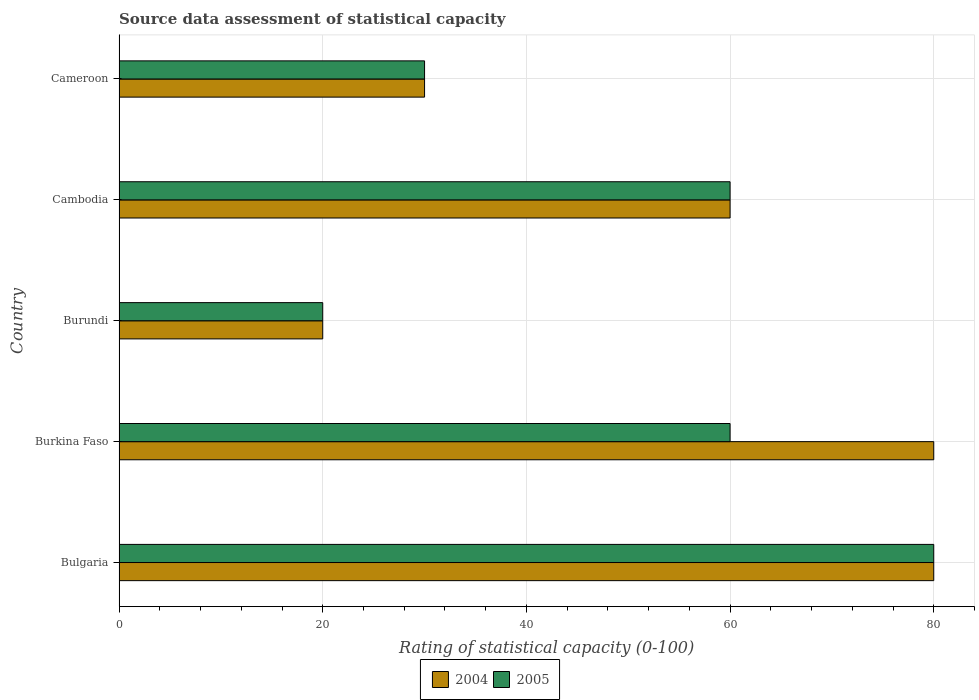Are the number of bars per tick equal to the number of legend labels?
Keep it short and to the point. Yes. Are the number of bars on each tick of the Y-axis equal?
Your response must be concise. Yes. What is the label of the 3rd group of bars from the top?
Ensure brevity in your answer.  Burundi. In which country was the rating of statistical capacity in 2005 maximum?
Make the answer very short. Bulgaria. In which country was the rating of statistical capacity in 2005 minimum?
Your answer should be compact. Burundi. What is the total rating of statistical capacity in 2005 in the graph?
Your answer should be very brief. 250. What is the difference between the rating of statistical capacity in 2004 in Bulgaria and that in Cameroon?
Your response must be concise. 50. What is the average rating of statistical capacity in 2005 per country?
Offer a terse response. 50. In how many countries, is the rating of statistical capacity in 2004 greater than 48 ?
Your response must be concise. 3. What is the ratio of the rating of statistical capacity in 2004 in Burkina Faso to that in Burundi?
Provide a short and direct response. 4. What is the difference between the highest and the second highest rating of statistical capacity in 2005?
Your answer should be very brief. 20. What does the 1st bar from the top in Cambodia represents?
Make the answer very short. 2005. Are all the bars in the graph horizontal?
Ensure brevity in your answer.  Yes. Are the values on the major ticks of X-axis written in scientific E-notation?
Ensure brevity in your answer.  No. Does the graph contain any zero values?
Ensure brevity in your answer.  No. Does the graph contain grids?
Your answer should be very brief. Yes. How are the legend labels stacked?
Provide a succinct answer. Horizontal. What is the title of the graph?
Provide a short and direct response. Source data assessment of statistical capacity. What is the label or title of the X-axis?
Your response must be concise. Rating of statistical capacity (0-100). What is the Rating of statistical capacity (0-100) in 2005 in Bulgaria?
Offer a very short reply. 80. What is the Rating of statistical capacity (0-100) in 2004 in Burundi?
Keep it short and to the point. 20. What is the Rating of statistical capacity (0-100) in 2004 in Cambodia?
Make the answer very short. 60. What is the Rating of statistical capacity (0-100) in 2005 in Cameroon?
Ensure brevity in your answer.  30. Across all countries, what is the maximum Rating of statistical capacity (0-100) in 2005?
Your response must be concise. 80. Across all countries, what is the minimum Rating of statistical capacity (0-100) of 2005?
Ensure brevity in your answer.  20. What is the total Rating of statistical capacity (0-100) of 2004 in the graph?
Your answer should be very brief. 270. What is the total Rating of statistical capacity (0-100) in 2005 in the graph?
Ensure brevity in your answer.  250. What is the difference between the Rating of statistical capacity (0-100) of 2004 in Bulgaria and that in Burkina Faso?
Offer a very short reply. 0. What is the difference between the Rating of statistical capacity (0-100) of 2005 in Bulgaria and that in Burkina Faso?
Provide a short and direct response. 20. What is the difference between the Rating of statistical capacity (0-100) of 2004 in Bulgaria and that in Burundi?
Ensure brevity in your answer.  60. What is the difference between the Rating of statistical capacity (0-100) of 2005 in Bulgaria and that in Burundi?
Your answer should be compact. 60. What is the difference between the Rating of statistical capacity (0-100) in 2004 in Burkina Faso and that in Burundi?
Your response must be concise. 60. What is the difference between the Rating of statistical capacity (0-100) of 2005 in Burkina Faso and that in Burundi?
Your answer should be very brief. 40. What is the difference between the Rating of statistical capacity (0-100) in 2004 in Burkina Faso and that in Cameroon?
Offer a terse response. 50. What is the difference between the Rating of statistical capacity (0-100) in 2005 in Burkina Faso and that in Cameroon?
Your answer should be very brief. 30. What is the difference between the Rating of statistical capacity (0-100) of 2004 in Burundi and that in Cambodia?
Ensure brevity in your answer.  -40. What is the difference between the Rating of statistical capacity (0-100) in 2005 in Burundi and that in Cambodia?
Your answer should be very brief. -40. What is the difference between the Rating of statistical capacity (0-100) of 2005 in Burundi and that in Cameroon?
Your answer should be very brief. -10. What is the difference between the Rating of statistical capacity (0-100) in 2004 in Bulgaria and the Rating of statistical capacity (0-100) in 2005 in Cambodia?
Your response must be concise. 20. What is the difference between the Rating of statistical capacity (0-100) of 2004 in Burkina Faso and the Rating of statistical capacity (0-100) of 2005 in Burundi?
Provide a succinct answer. 60. What is the difference between the Rating of statistical capacity (0-100) in 2004 in Burkina Faso and the Rating of statistical capacity (0-100) in 2005 in Cambodia?
Provide a short and direct response. 20. What is the difference between the Rating of statistical capacity (0-100) in 2004 in Burkina Faso and the Rating of statistical capacity (0-100) in 2005 in Cameroon?
Provide a succinct answer. 50. What is the difference between the Rating of statistical capacity (0-100) of 2004 in Burundi and the Rating of statistical capacity (0-100) of 2005 in Cambodia?
Offer a very short reply. -40. What is the difference between the Rating of statistical capacity (0-100) in 2004 in Burundi and the Rating of statistical capacity (0-100) in 2005 in Cameroon?
Ensure brevity in your answer.  -10. What is the difference between the Rating of statistical capacity (0-100) of 2004 and Rating of statistical capacity (0-100) of 2005 in Bulgaria?
Your response must be concise. 0. What is the difference between the Rating of statistical capacity (0-100) in 2004 and Rating of statistical capacity (0-100) in 2005 in Cambodia?
Offer a very short reply. 0. What is the difference between the Rating of statistical capacity (0-100) in 2004 and Rating of statistical capacity (0-100) in 2005 in Cameroon?
Make the answer very short. 0. What is the ratio of the Rating of statistical capacity (0-100) in 2005 in Bulgaria to that in Cambodia?
Give a very brief answer. 1.33. What is the ratio of the Rating of statistical capacity (0-100) of 2004 in Bulgaria to that in Cameroon?
Offer a very short reply. 2.67. What is the ratio of the Rating of statistical capacity (0-100) of 2005 in Bulgaria to that in Cameroon?
Your answer should be compact. 2.67. What is the ratio of the Rating of statistical capacity (0-100) in 2004 in Burkina Faso to that in Burundi?
Keep it short and to the point. 4. What is the ratio of the Rating of statistical capacity (0-100) in 2004 in Burkina Faso to that in Cambodia?
Provide a short and direct response. 1.33. What is the ratio of the Rating of statistical capacity (0-100) in 2004 in Burkina Faso to that in Cameroon?
Offer a terse response. 2.67. What is the ratio of the Rating of statistical capacity (0-100) of 2005 in Burkina Faso to that in Cameroon?
Provide a short and direct response. 2. What is the ratio of the Rating of statistical capacity (0-100) in 2004 in Burundi to that in Cameroon?
Ensure brevity in your answer.  0.67. What is the ratio of the Rating of statistical capacity (0-100) of 2004 in Cambodia to that in Cameroon?
Offer a very short reply. 2. What is the difference between the highest and the second highest Rating of statistical capacity (0-100) of 2005?
Offer a very short reply. 20. What is the difference between the highest and the lowest Rating of statistical capacity (0-100) in 2004?
Offer a very short reply. 60. What is the difference between the highest and the lowest Rating of statistical capacity (0-100) in 2005?
Offer a very short reply. 60. 